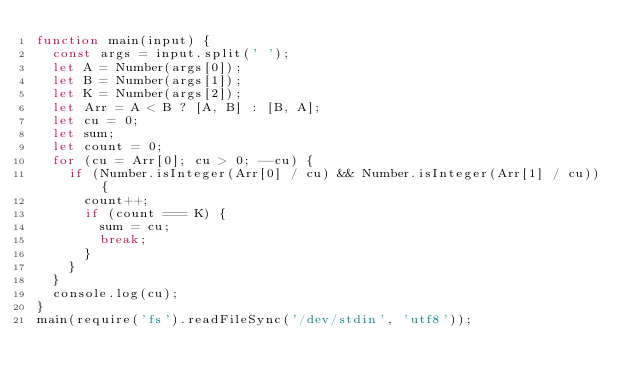<code> <loc_0><loc_0><loc_500><loc_500><_JavaScript_>function main(input) {
  const args = input.split(' ');
  let A = Number(args[0]);
  let B = Number(args[1]);
  let K = Number(args[2]);
  let Arr = A < B ? [A, B] : [B, A];
  let cu = 0;
  let sum;
  let count = 0;
  for (cu = Arr[0]; cu > 0; --cu) {
    if (Number.isInteger(Arr[0] / cu) && Number.isInteger(Arr[1] / cu)) {
      count++;
      if (count === K) {
        sum = cu;
        break;
      }
    }
  }
  console.log(cu);
}
main(require('fs').readFileSync('/dev/stdin', 'utf8'));

</code> 